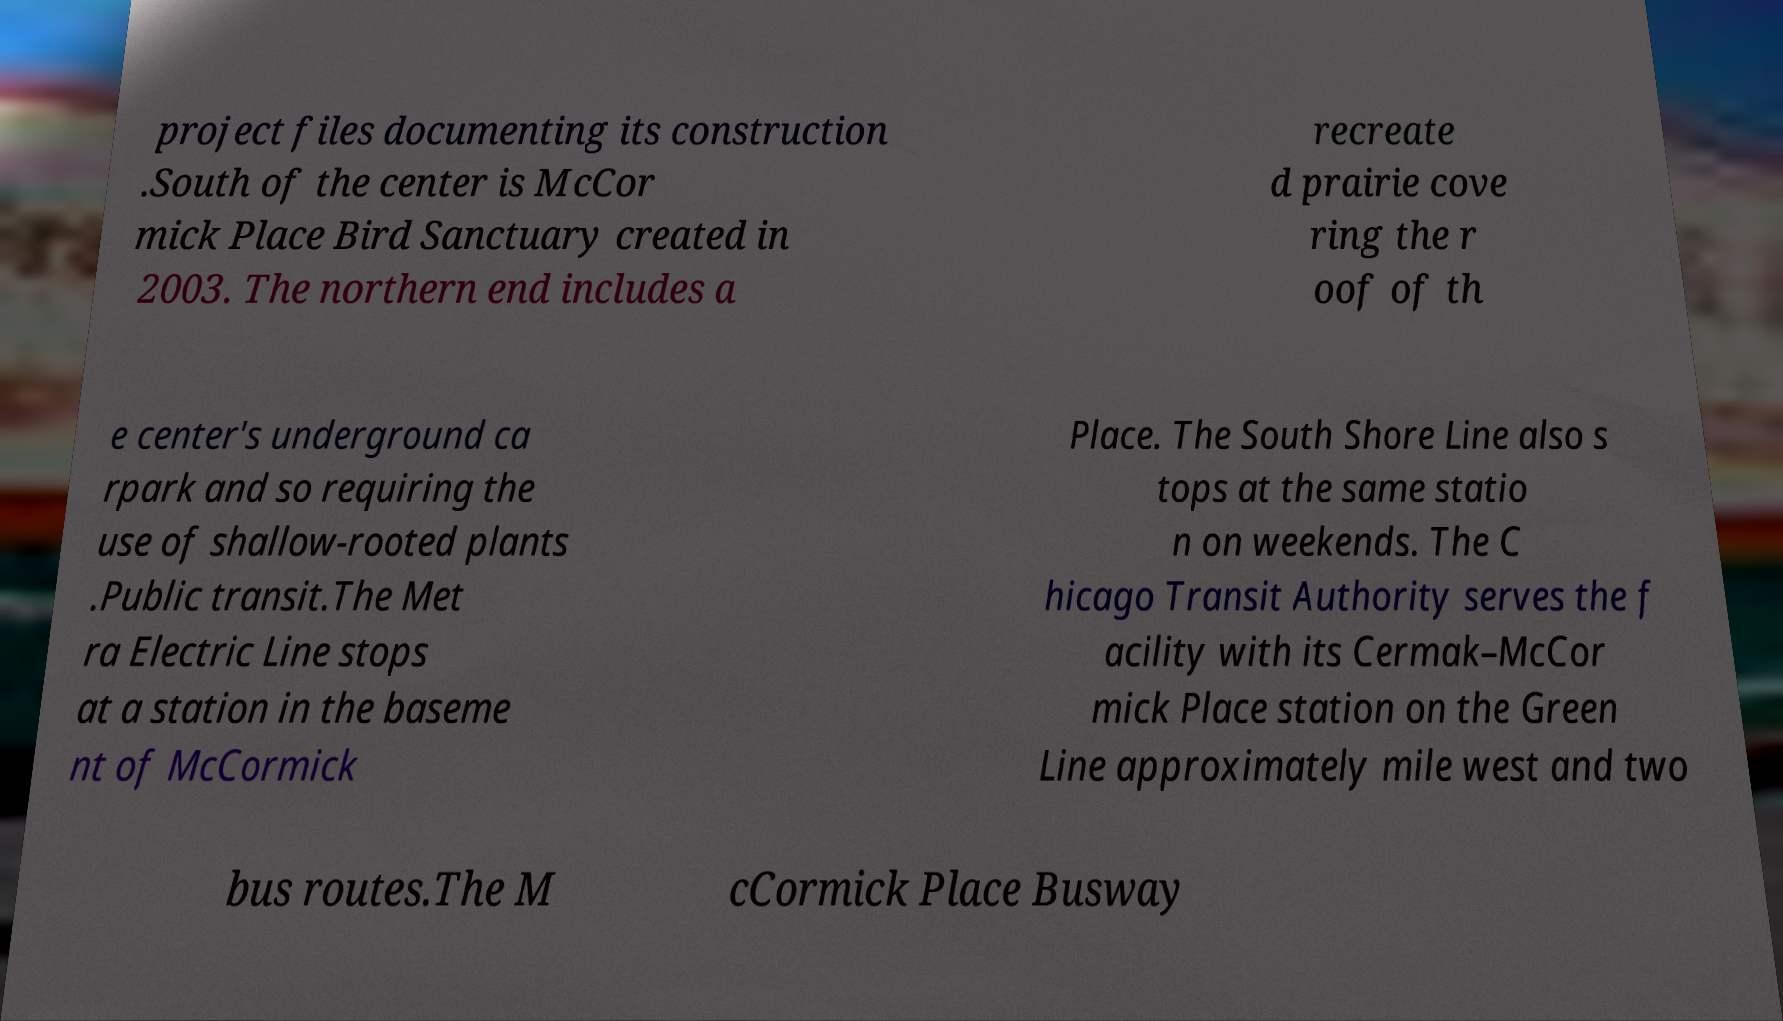What messages or text are displayed in this image? I need them in a readable, typed format. project files documenting its construction .South of the center is McCor mick Place Bird Sanctuary created in 2003. The northern end includes a recreate d prairie cove ring the r oof of th e center's underground ca rpark and so requiring the use of shallow-rooted plants .Public transit.The Met ra Electric Line stops at a station in the baseme nt of McCormick Place. The South Shore Line also s tops at the same statio n on weekends. The C hicago Transit Authority serves the f acility with its Cermak–McCor mick Place station on the Green Line approximately mile west and two bus routes.The M cCormick Place Busway 